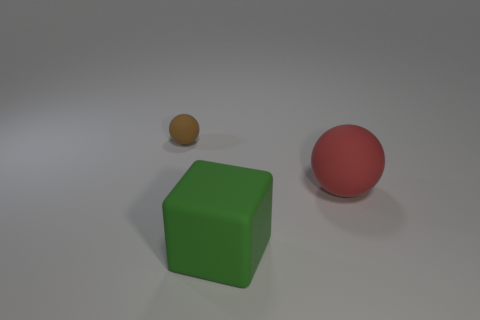Are there any shadows visible, and what do they tell us about the lighting? Yes, there are subtle shadows cast by each object, slightly elongated and soft-edged, suggesting that the light source is not too harsh and is likely positioned above and possibly slightly in front of the objects, indicating a controlled lighting environment typical for studio photography. 